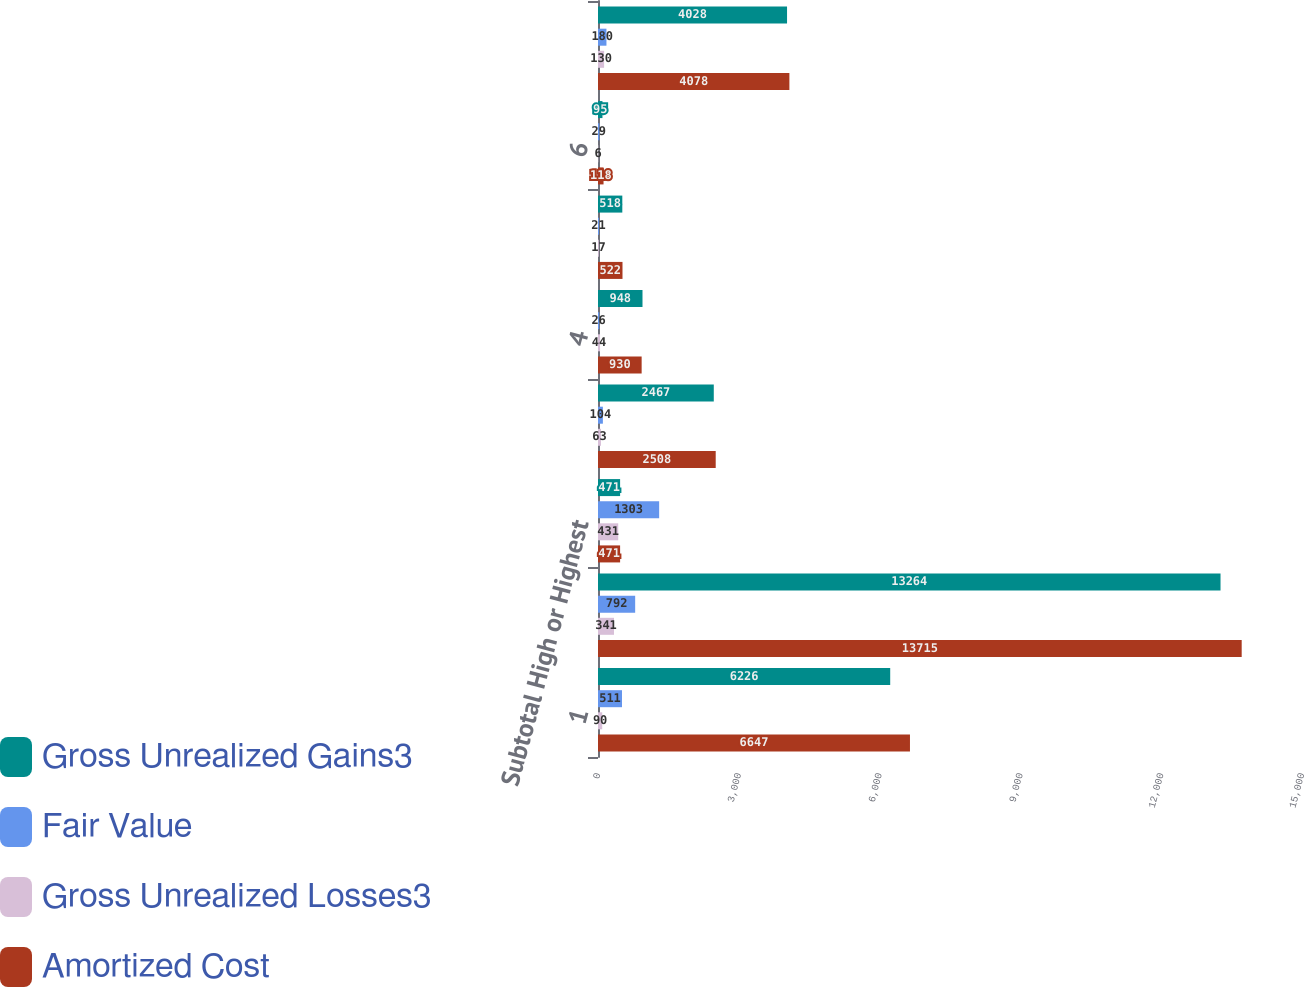Convert chart to OTSL. <chart><loc_0><loc_0><loc_500><loc_500><stacked_bar_chart><ecel><fcel>1<fcel>2<fcel>Subtotal High or Highest<fcel>3<fcel>4<fcel>5<fcel>6<fcel>Subtotal Other Securities(4)<nl><fcel>Gross Unrealized Gains3<fcel>6226<fcel>13264<fcel>471<fcel>2467<fcel>948<fcel>518<fcel>95<fcel>4028<nl><fcel>Fair Value<fcel>511<fcel>792<fcel>1303<fcel>104<fcel>26<fcel>21<fcel>29<fcel>180<nl><fcel>Gross Unrealized Losses3<fcel>90<fcel>341<fcel>431<fcel>63<fcel>44<fcel>17<fcel>6<fcel>130<nl><fcel>Amortized Cost<fcel>6647<fcel>13715<fcel>471<fcel>2508<fcel>930<fcel>522<fcel>118<fcel>4078<nl></chart> 